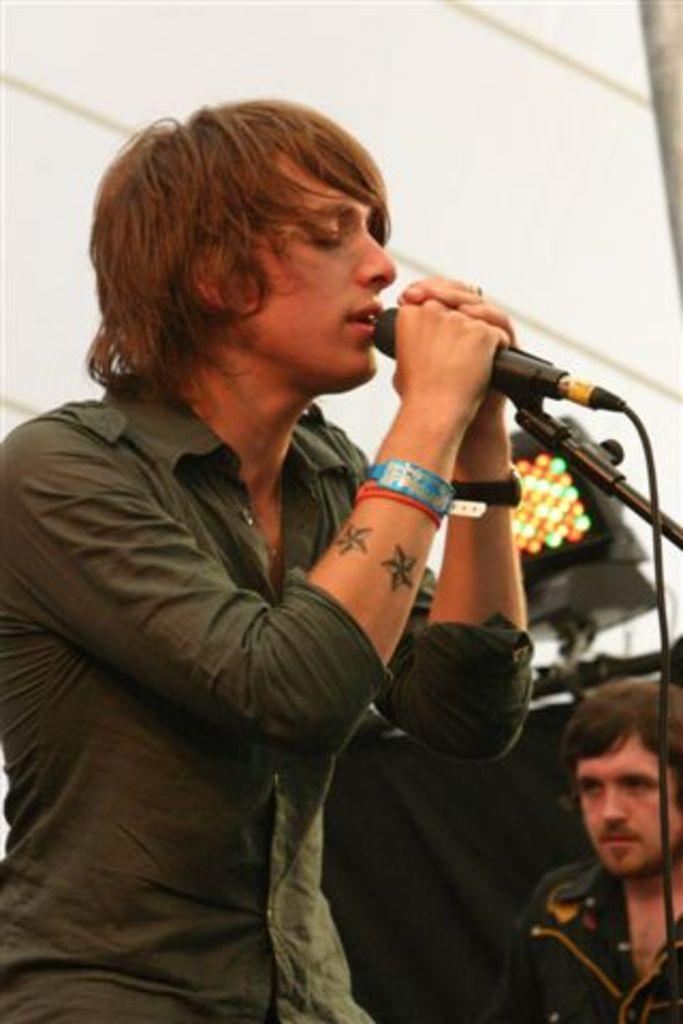What is the man in the image doing? The man is singing in the image. What object is the man holding in his hand? The man is holding a microphone in his hand. What accessories is the man wearing on his wrist? The man is wearing a watch and a wristband. How many men are visible in the image? There are two men visible in the image. What can be seen in the image that provides light? There is a light in the image. What type of bears can be seen playing with the man's aunt in the image? There are no bears or the man's aunt present in the image. 